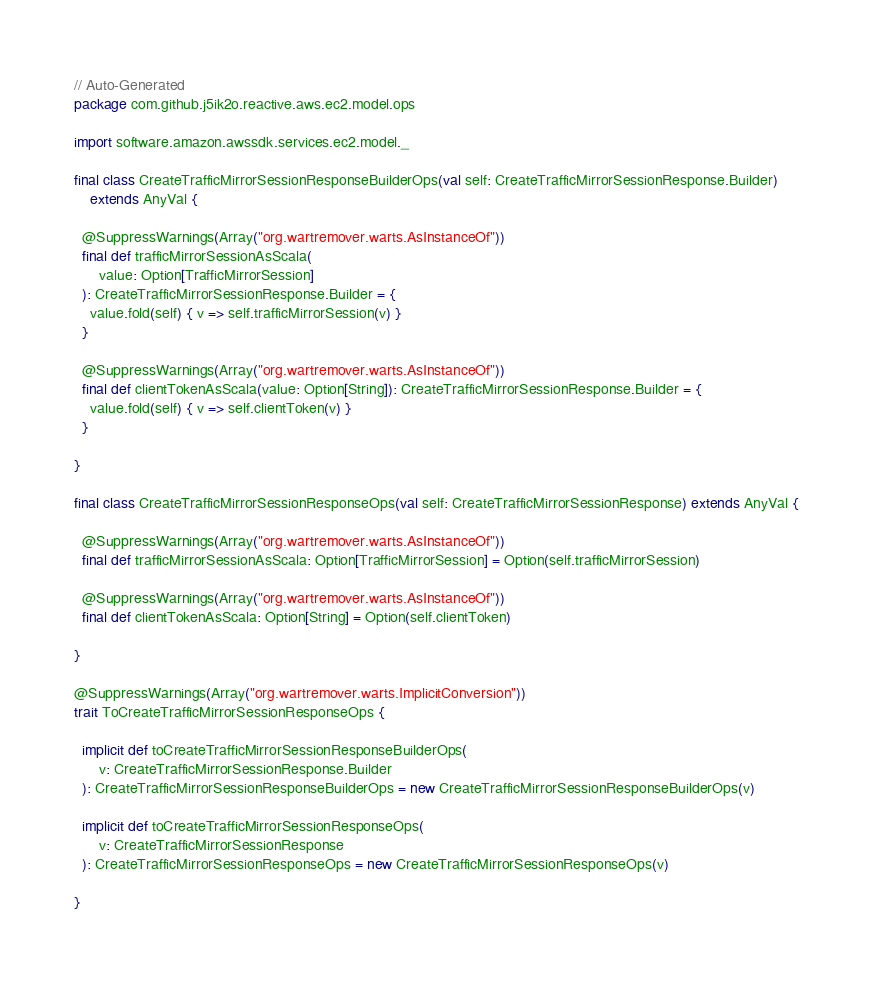<code> <loc_0><loc_0><loc_500><loc_500><_Scala_>// Auto-Generated
package com.github.j5ik2o.reactive.aws.ec2.model.ops

import software.amazon.awssdk.services.ec2.model._

final class CreateTrafficMirrorSessionResponseBuilderOps(val self: CreateTrafficMirrorSessionResponse.Builder)
    extends AnyVal {

  @SuppressWarnings(Array("org.wartremover.warts.AsInstanceOf"))
  final def trafficMirrorSessionAsScala(
      value: Option[TrafficMirrorSession]
  ): CreateTrafficMirrorSessionResponse.Builder = {
    value.fold(self) { v => self.trafficMirrorSession(v) }
  }

  @SuppressWarnings(Array("org.wartremover.warts.AsInstanceOf"))
  final def clientTokenAsScala(value: Option[String]): CreateTrafficMirrorSessionResponse.Builder = {
    value.fold(self) { v => self.clientToken(v) }
  }

}

final class CreateTrafficMirrorSessionResponseOps(val self: CreateTrafficMirrorSessionResponse) extends AnyVal {

  @SuppressWarnings(Array("org.wartremover.warts.AsInstanceOf"))
  final def trafficMirrorSessionAsScala: Option[TrafficMirrorSession] = Option(self.trafficMirrorSession)

  @SuppressWarnings(Array("org.wartremover.warts.AsInstanceOf"))
  final def clientTokenAsScala: Option[String] = Option(self.clientToken)

}

@SuppressWarnings(Array("org.wartremover.warts.ImplicitConversion"))
trait ToCreateTrafficMirrorSessionResponseOps {

  implicit def toCreateTrafficMirrorSessionResponseBuilderOps(
      v: CreateTrafficMirrorSessionResponse.Builder
  ): CreateTrafficMirrorSessionResponseBuilderOps = new CreateTrafficMirrorSessionResponseBuilderOps(v)

  implicit def toCreateTrafficMirrorSessionResponseOps(
      v: CreateTrafficMirrorSessionResponse
  ): CreateTrafficMirrorSessionResponseOps = new CreateTrafficMirrorSessionResponseOps(v)

}
</code> 